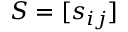Convert formula to latex. <formula><loc_0><loc_0><loc_500><loc_500>S = [ s _ { i j } ]</formula> 